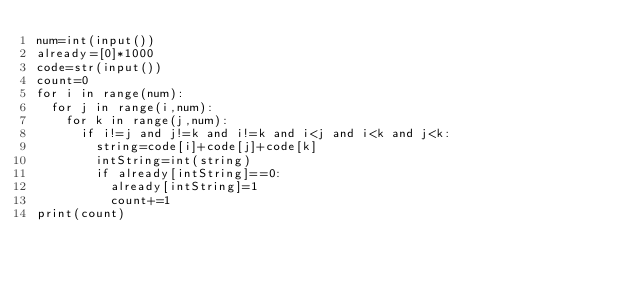Convert code to text. <code><loc_0><loc_0><loc_500><loc_500><_Python_>num=int(input())
already=[0]*1000
code=str(input())
count=0
for i in range(num):
  for j in range(i,num):
    for k in range(j,num):
      if i!=j and j!=k and i!=k and i<j and i<k and j<k:
      	string=code[i]+code[j]+code[k]
      	intString=int(string)
      	if already[intString]==0:
          already[intString]=1
          count+=1
print(count)</code> 